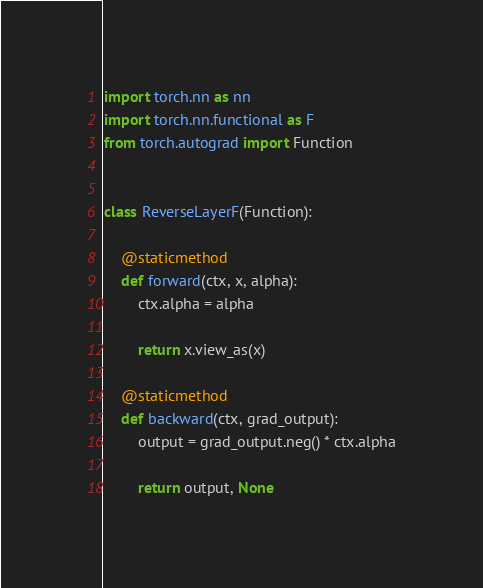Convert code to text. <code><loc_0><loc_0><loc_500><loc_500><_Python_>import torch.nn as nn
import torch.nn.functional as F
from torch.autograd import Function


class ReverseLayerF(Function):

    @staticmethod
    def forward(ctx, x, alpha):
        ctx.alpha = alpha

        return x.view_as(x)

    @staticmethod
    def backward(ctx, grad_output):
        output = grad_output.neg() * ctx.alpha

        return output, None</code> 